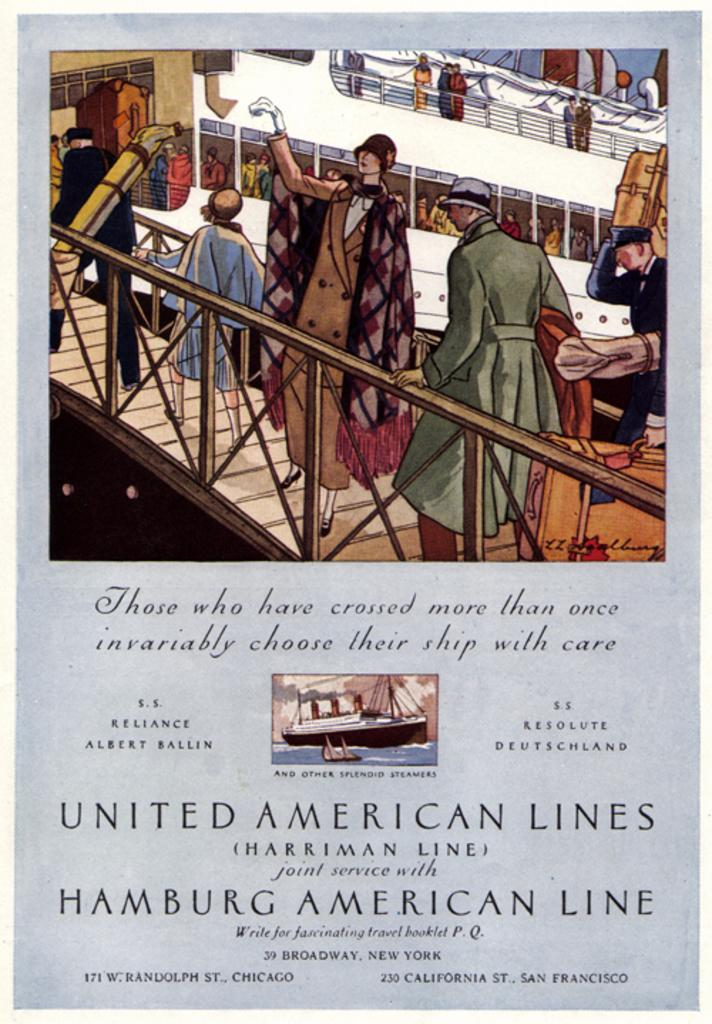What is the nature of the image? The image is edited and animated. What can be found on the image besides the animated elements? There are texts written on the image. What is the main subject of the image? There are persons in the image. What type of vehicle is present in the image? There is a ship in the image, and it is white in color. Are there any people on the ship? Yes, there are persons on the ship. What type of grape is being used to put out the fire on the ship in the image? There is no fire or grape present in the image; it features a white ship with persons on it. 